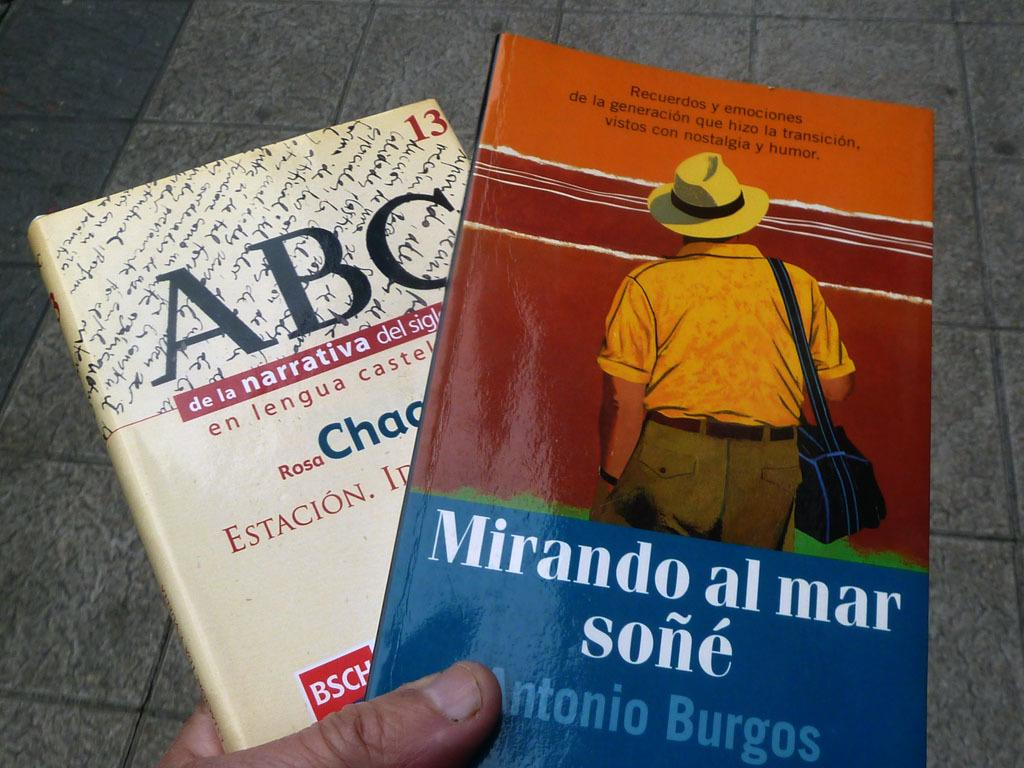Provide a one-sentence caption for the provided image. A hand holds two books, one written by Antonio Burgos. 